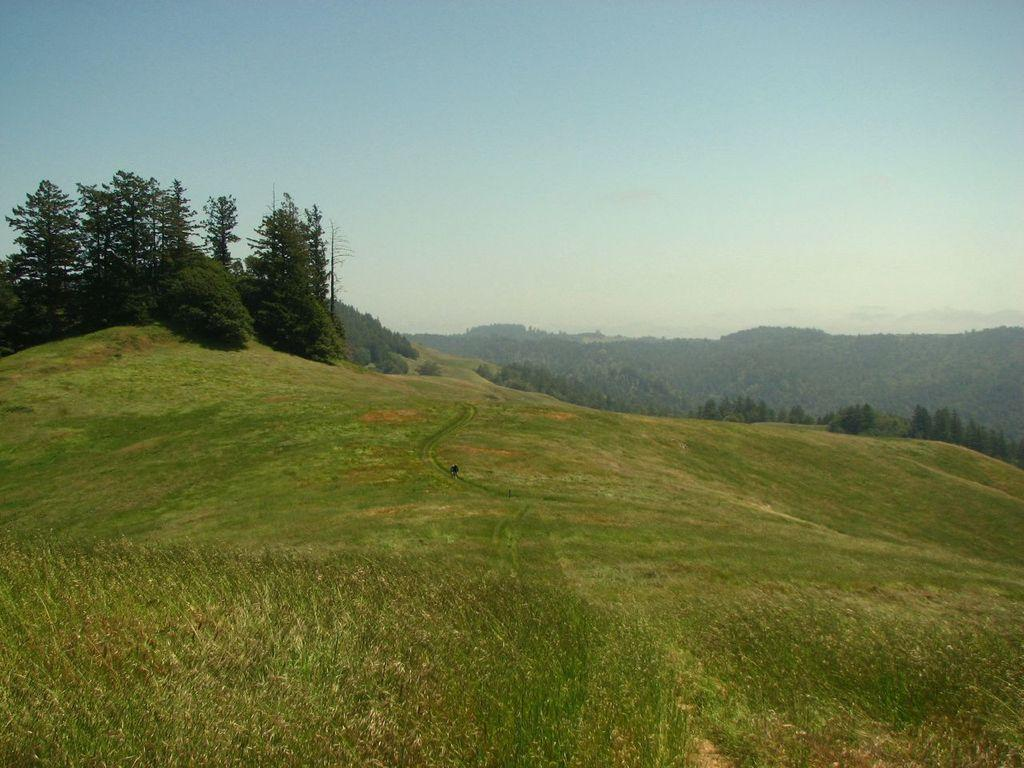What type of setting is depicted in the image? The image is an outside view. What type of vegetation is present at the bottom of the image? There is grass at the bottom of the image. What can be seen in the background of the image? There are many trees in the background of the image. What is visible at the top of the image? The sky is visible at the top of the image. What type of map is visible in the image? There is no map present in the image; it is an outside view with grass, trees, and the sky. 